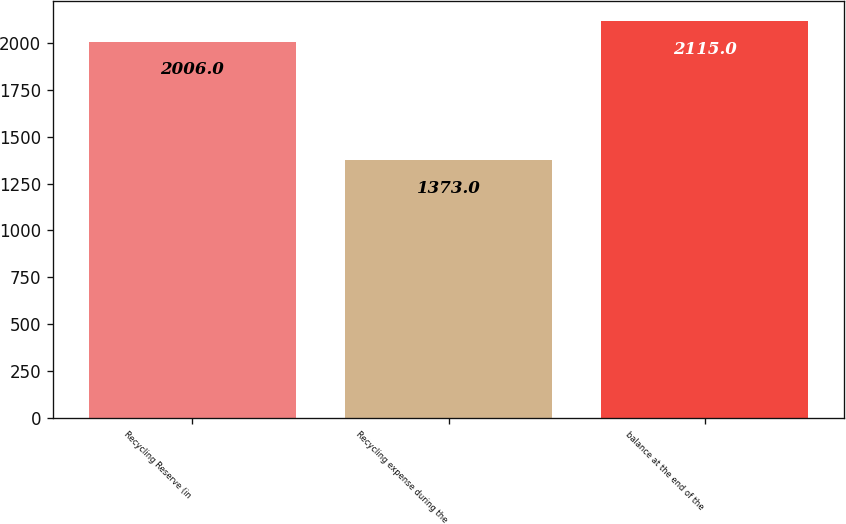Convert chart. <chart><loc_0><loc_0><loc_500><loc_500><bar_chart><fcel>Recycling Reserve (in<fcel>Recycling expense during the<fcel>balance at the end of the<nl><fcel>2006<fcel>1373<fcel>2115<nl></chart> 